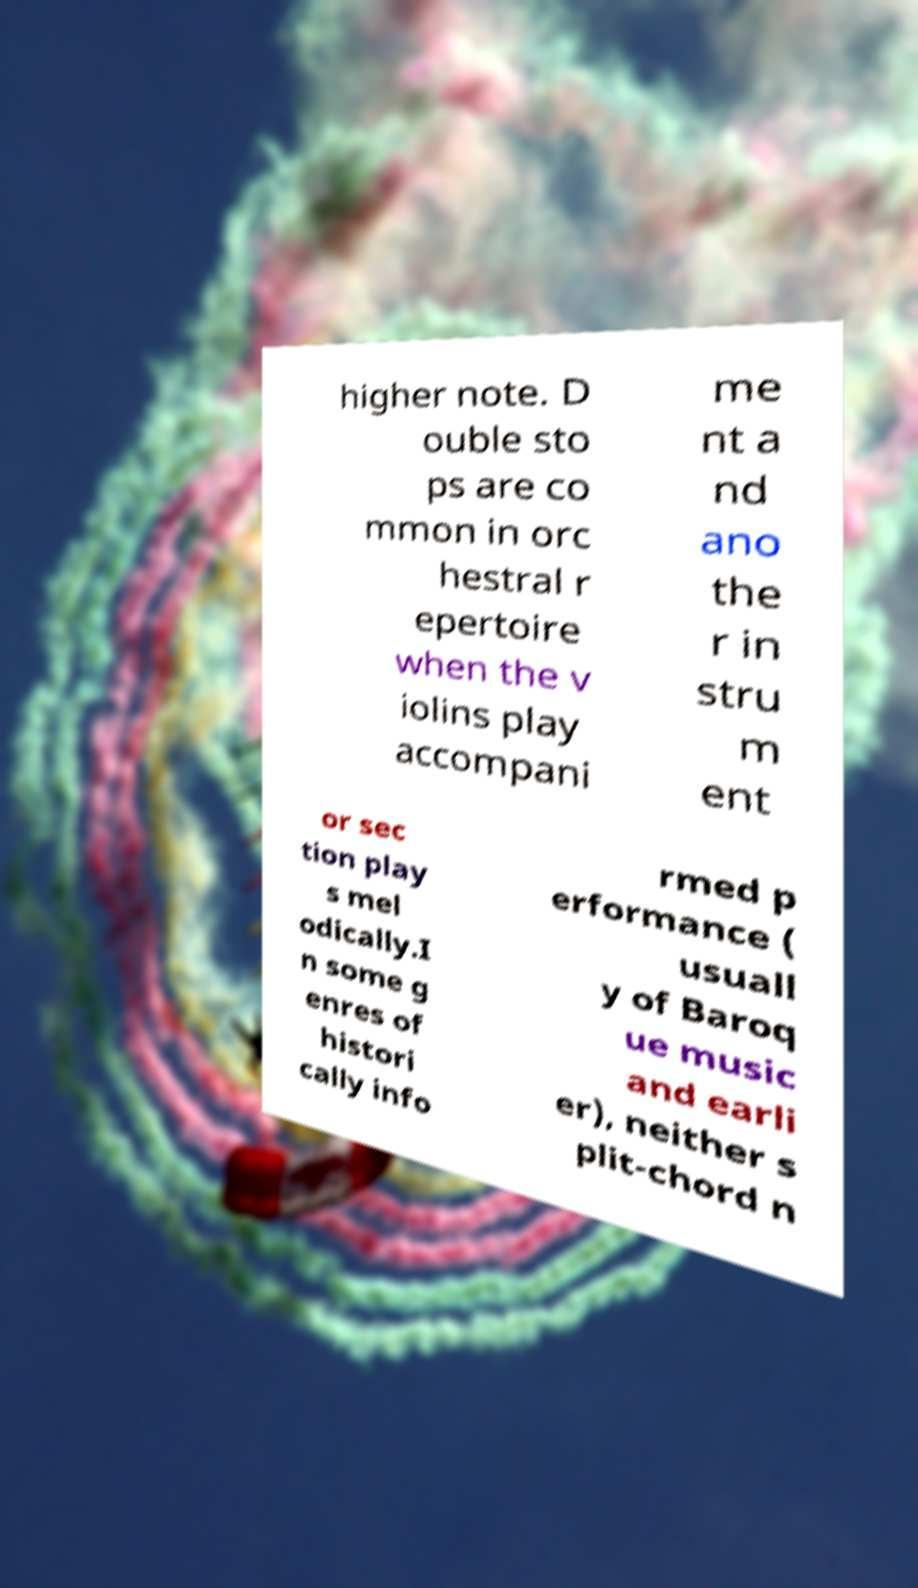For documentation purposes, I need the text within this image transcribed. Could you provide that? higher note. D ouble sto ps are co mmon in orc hestral r epertoire when the v iolins play accompani me nt a nd ano the r in stru m ent or sec tion play s mel odically.I n some g enres of histori cally info rmed p erformance ( usuall y of Baroq ue music and earli er), neither s plit-chord n 